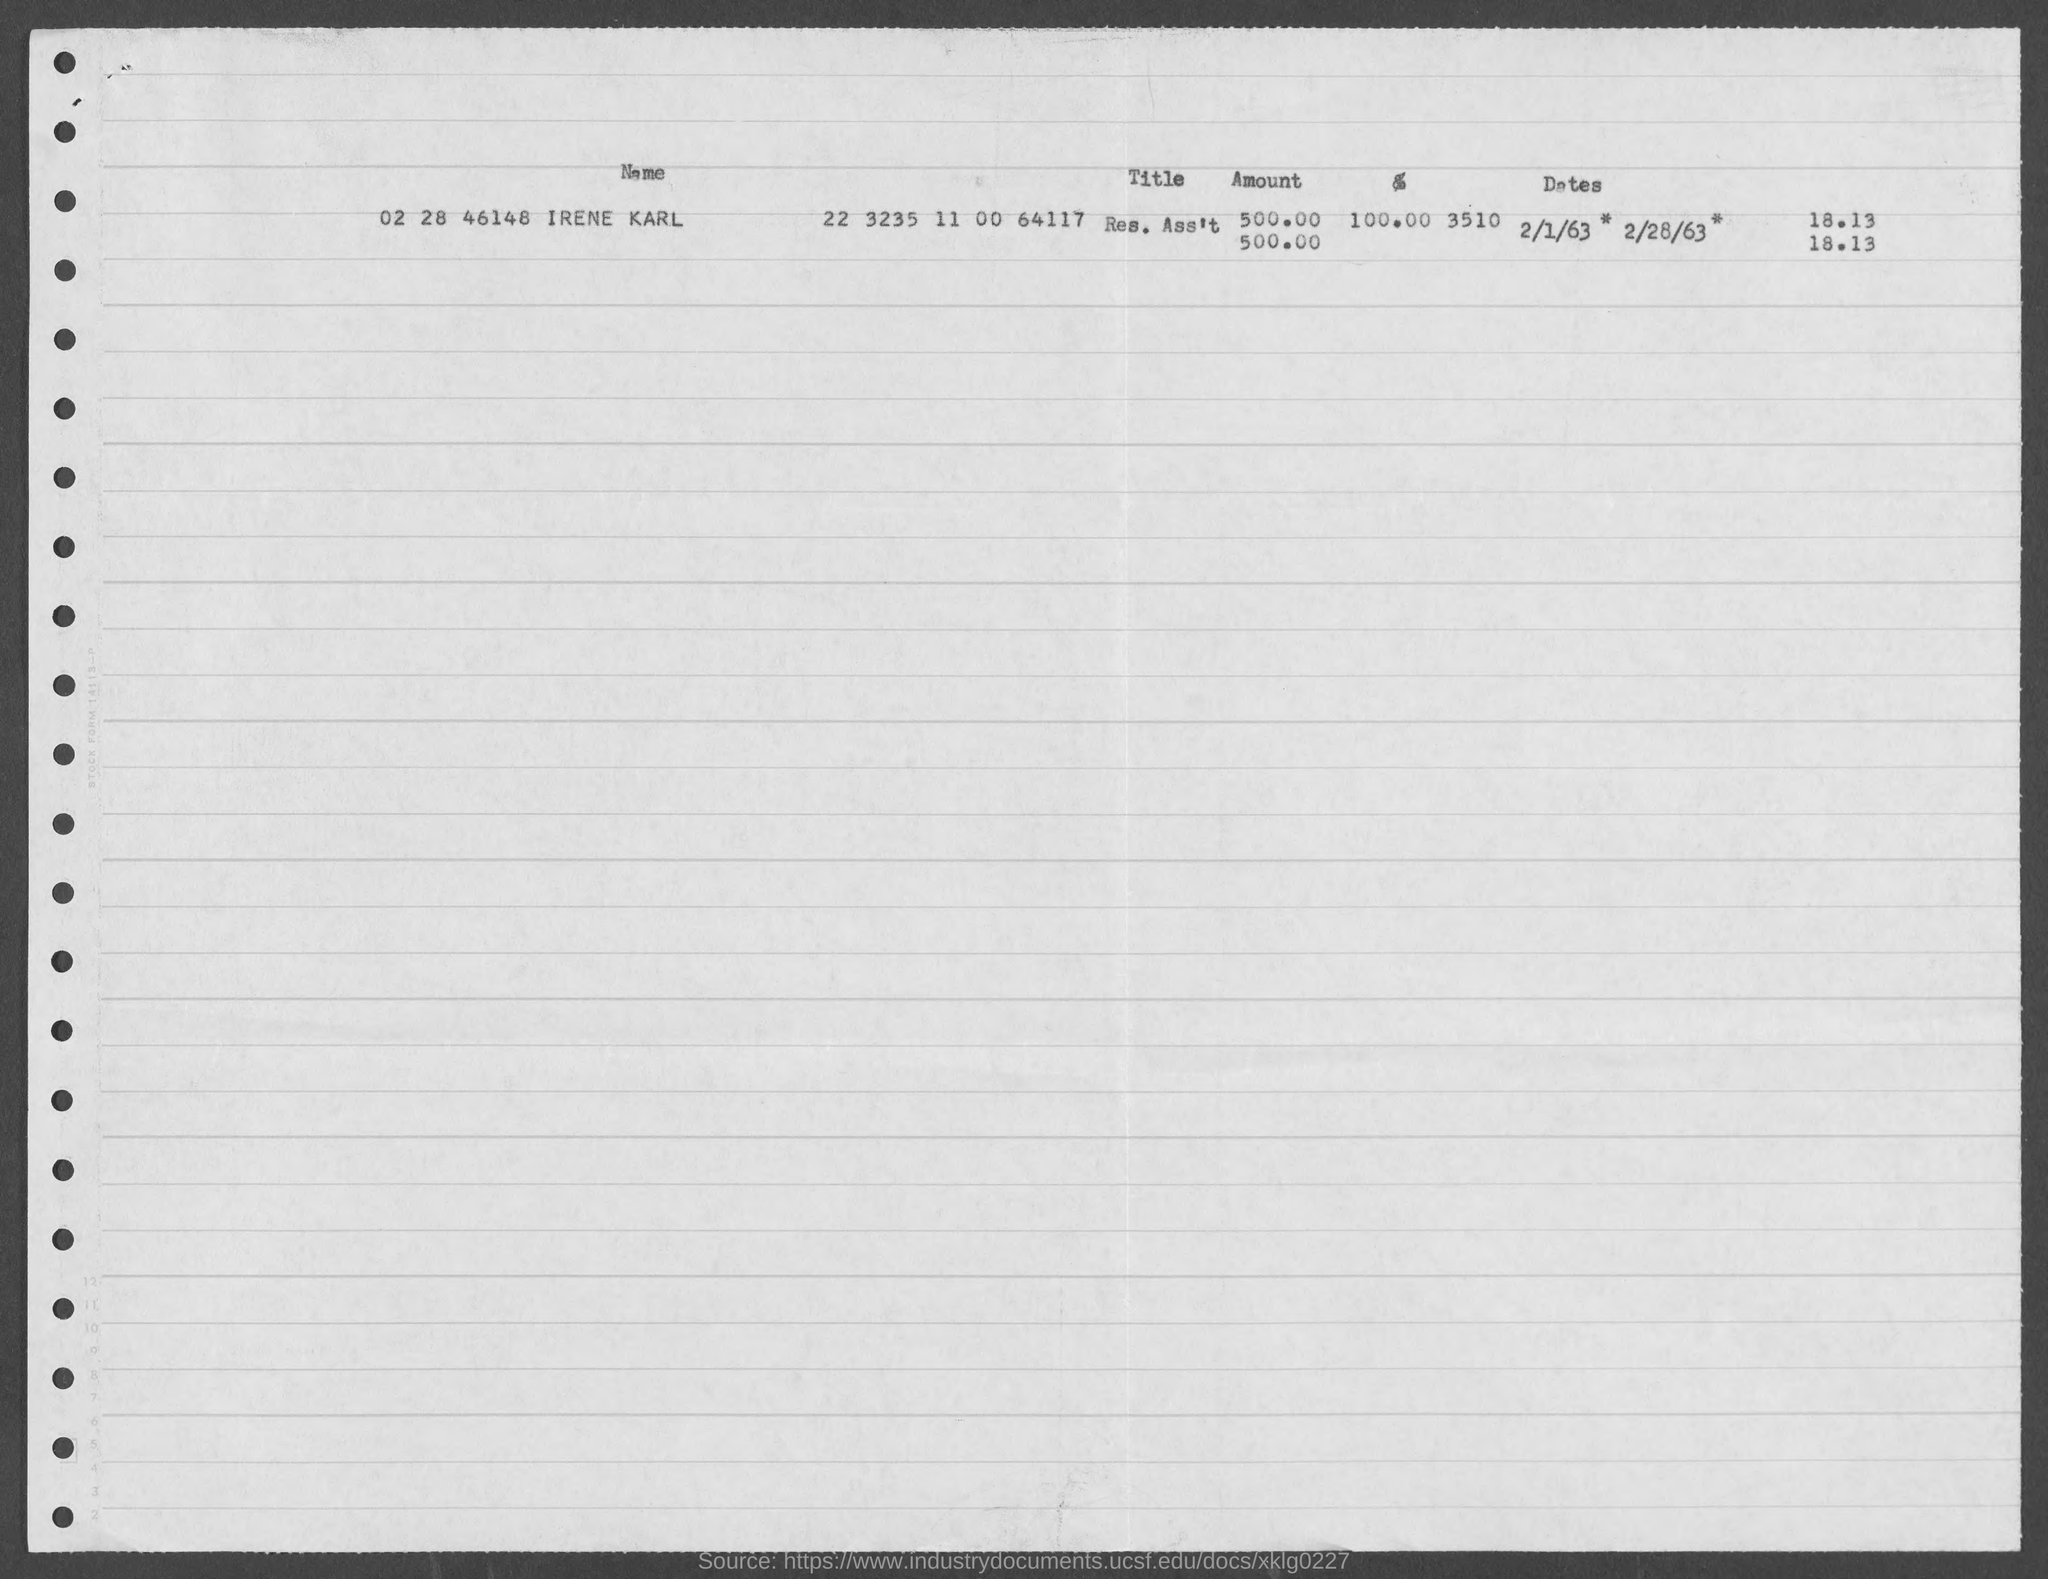Outline some significant characteristics in this image. The amount is 500.00. What is the title of the position? I am the Research Assistant. The name of the person is Irene Karl. 